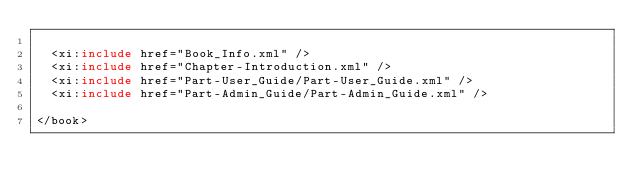Convert code to text. <code><loc_0><loc_0><loc_500><loc_500><_XML_>
	<xi:include href="Book_Info.xml" />
	<xi:include href="Chapter-Introduction.xml" />
	<xi:include href="Part-User_Guide/Part-User_Guide.xml" />
	<xi:include href="Part-Admin_Guide/Part-Admin_Guide.xml" />

</book>
</code> 